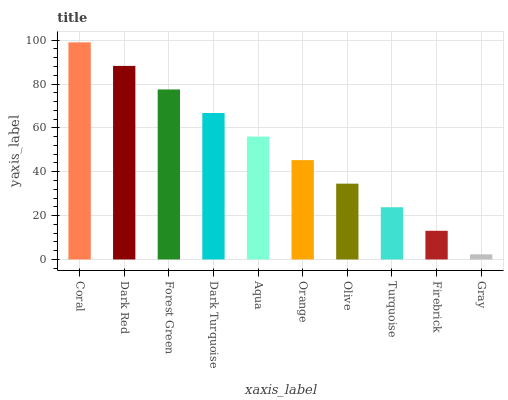Is Gray the minimum?
Answer yes or no. Yes. Is Coral the maximum?
Answer yes or no. Yes. Is Dark Red the minimum?
Answer yes or no. No. Is Dark Red the maximum?
Answer yes or no. No. Is Coral greater than Dark Red?
Answer yes or no. Yes. Is Dark Red less than Coral?
Answer yes or no. Yes. Is Dark Red greater than Coral?
Answer yes or no. No. Is Coral less than Dark Red?
Answer yes or no. No. Is Aqua the high median?
Answer yes or no. Yes. Is Orange the low median?
Answer yes or no. Yes. Is Dark Turquoise the high median?
Answer yes or no. No. Is Olive the low median?
Answer yes or no. No. 